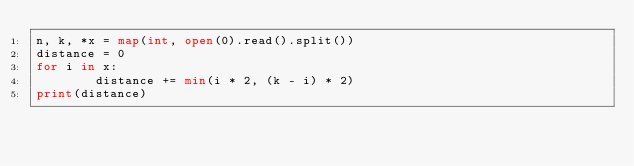<code> <loc_0><loc_0><loc_500><loc_500><_Python_>n, k, *x = map(int, open(0).read().split())
distance = 0 
for i in x:
        distance += min(i * 2, (k - i) * 2)
print(distance)</code> 